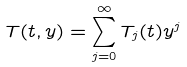Convert formula to latex. <formula><loc_0><loc_0><loc_500><loc_500>T ( t , y ) = \sum ^ { \infty } _ { j = 0 } T _ { j } ( t ) y ^ { j }</formula> 